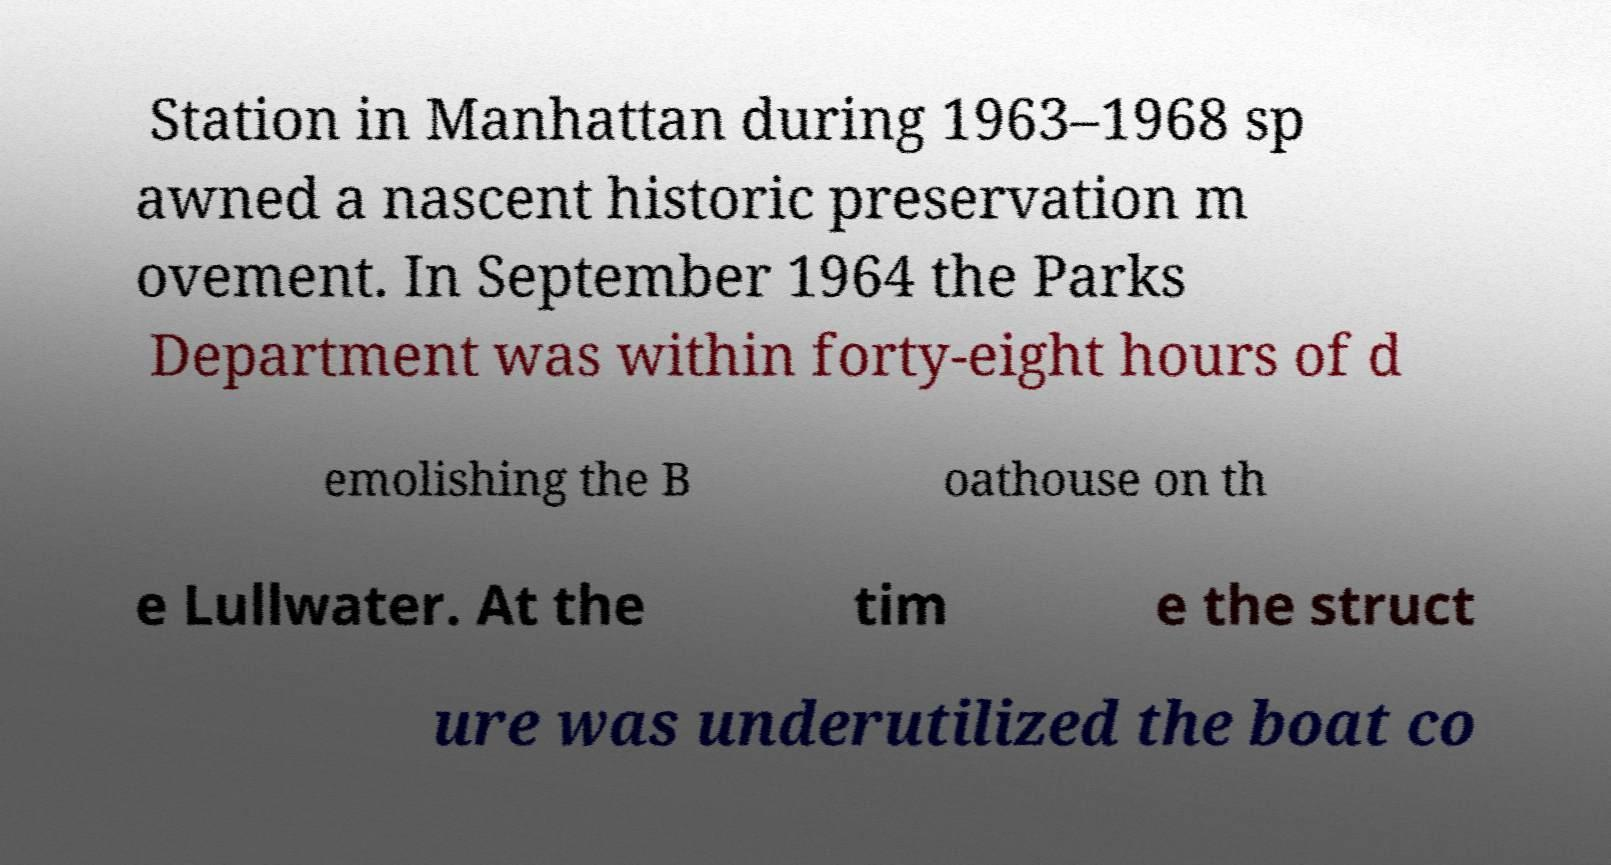Please read and relay the text visible in this image. What does it say? Station in Manhattan during 1963–1968 sp awned a nascent historic preservation m ovement. In September 1964 the Parks Department was within forty-eight hours of d emolishing the B oathouse on th e Lullwater. At the tim e the struct ure was underutilized the boat co 